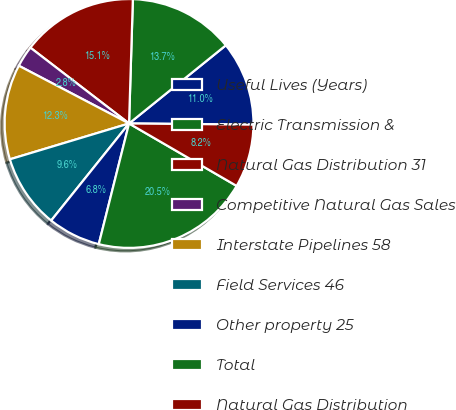Convert chart. <chart><loc_0><loc_0><loc_500><loc_500><pie_chart><fcel>Useful Lives (Years)<fcel>Electric Transmission &<fcel>Natural Gas Distribution 31<fcel>Competitive Natural Gas Sales<fcel>Interstate Pipelines 58<fcel>Field Services 46<fcel>Other property 25<fcel>Total<fcel>Natural Gas Distribution<nl><fcel>10.96%<fcel>13.7%<fcel>15.06%<fcel>2.75%<fcel>12.33%<fcel>9.59%<fcel>6.85%<fcel>20.54%<fcel>8.22%<nl></chart> 